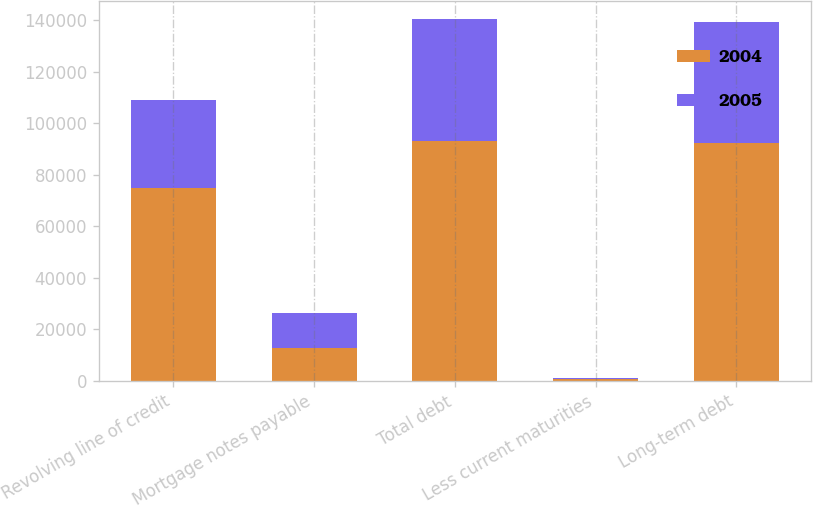Convert chart to OTSL. <chart><loc_0><loc_0><loc_500><loc_500><stacked_bar_chart><ecel><fcel>Revolving line of credit<fcel>Mortgage notes payable<fcel>Total debt<fcel>Less current maturities<fcel>Long-term debt<nl><fcel>2004<fcel>75000<fcel>12974<fcel>93147<fcel>699<fcel>92448<nl><fcel>2005<fcel>34000<fcel>13459<fcel>47459<fcel>486<fcel>46973<nl></chart> 